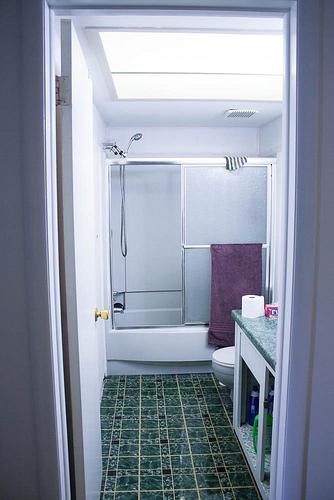Question: what is bright?
Choices:
A. Sun.
B. Moon.
C. Flash.
D. A light.
Answer with the letter. Answer: D Question: where is green tile?
Choices:
A. On the wall.
B. Ceiling.
C. In a box.
D. On the floor.
Answer with the letter. Answer: D Question: why is there sliding doors?
Choices:
A. For the patio.
B. For the shower.
C. For the deck.
D. For the wide opening.
Answer with the letter. Answer: B Question: what is on the hand rail?
Choices:
A. A towel.
B. Tie.
C. Shirt.
D. Book.
Answer with the letter. Answer: A Question: what color is the towel?
Choices:
A. Blue.
B. Purple.
C. Pink.
D. Yellow.
Answer with the letter. Answer: B 